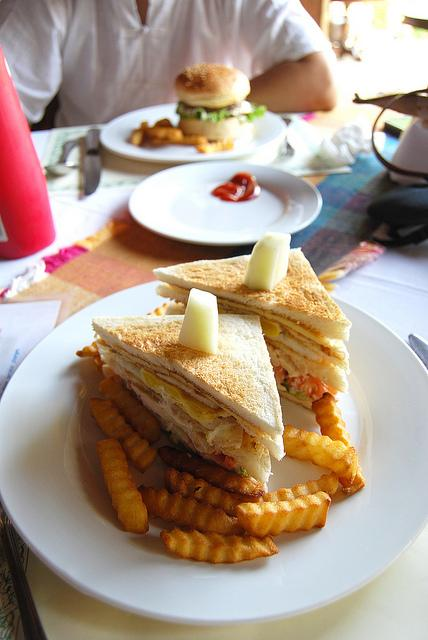What is used the make the fries have that shape?

Choices:
A) crinkle cutter
B) spatula
C) fork
D) steak knife crinkle cutter 